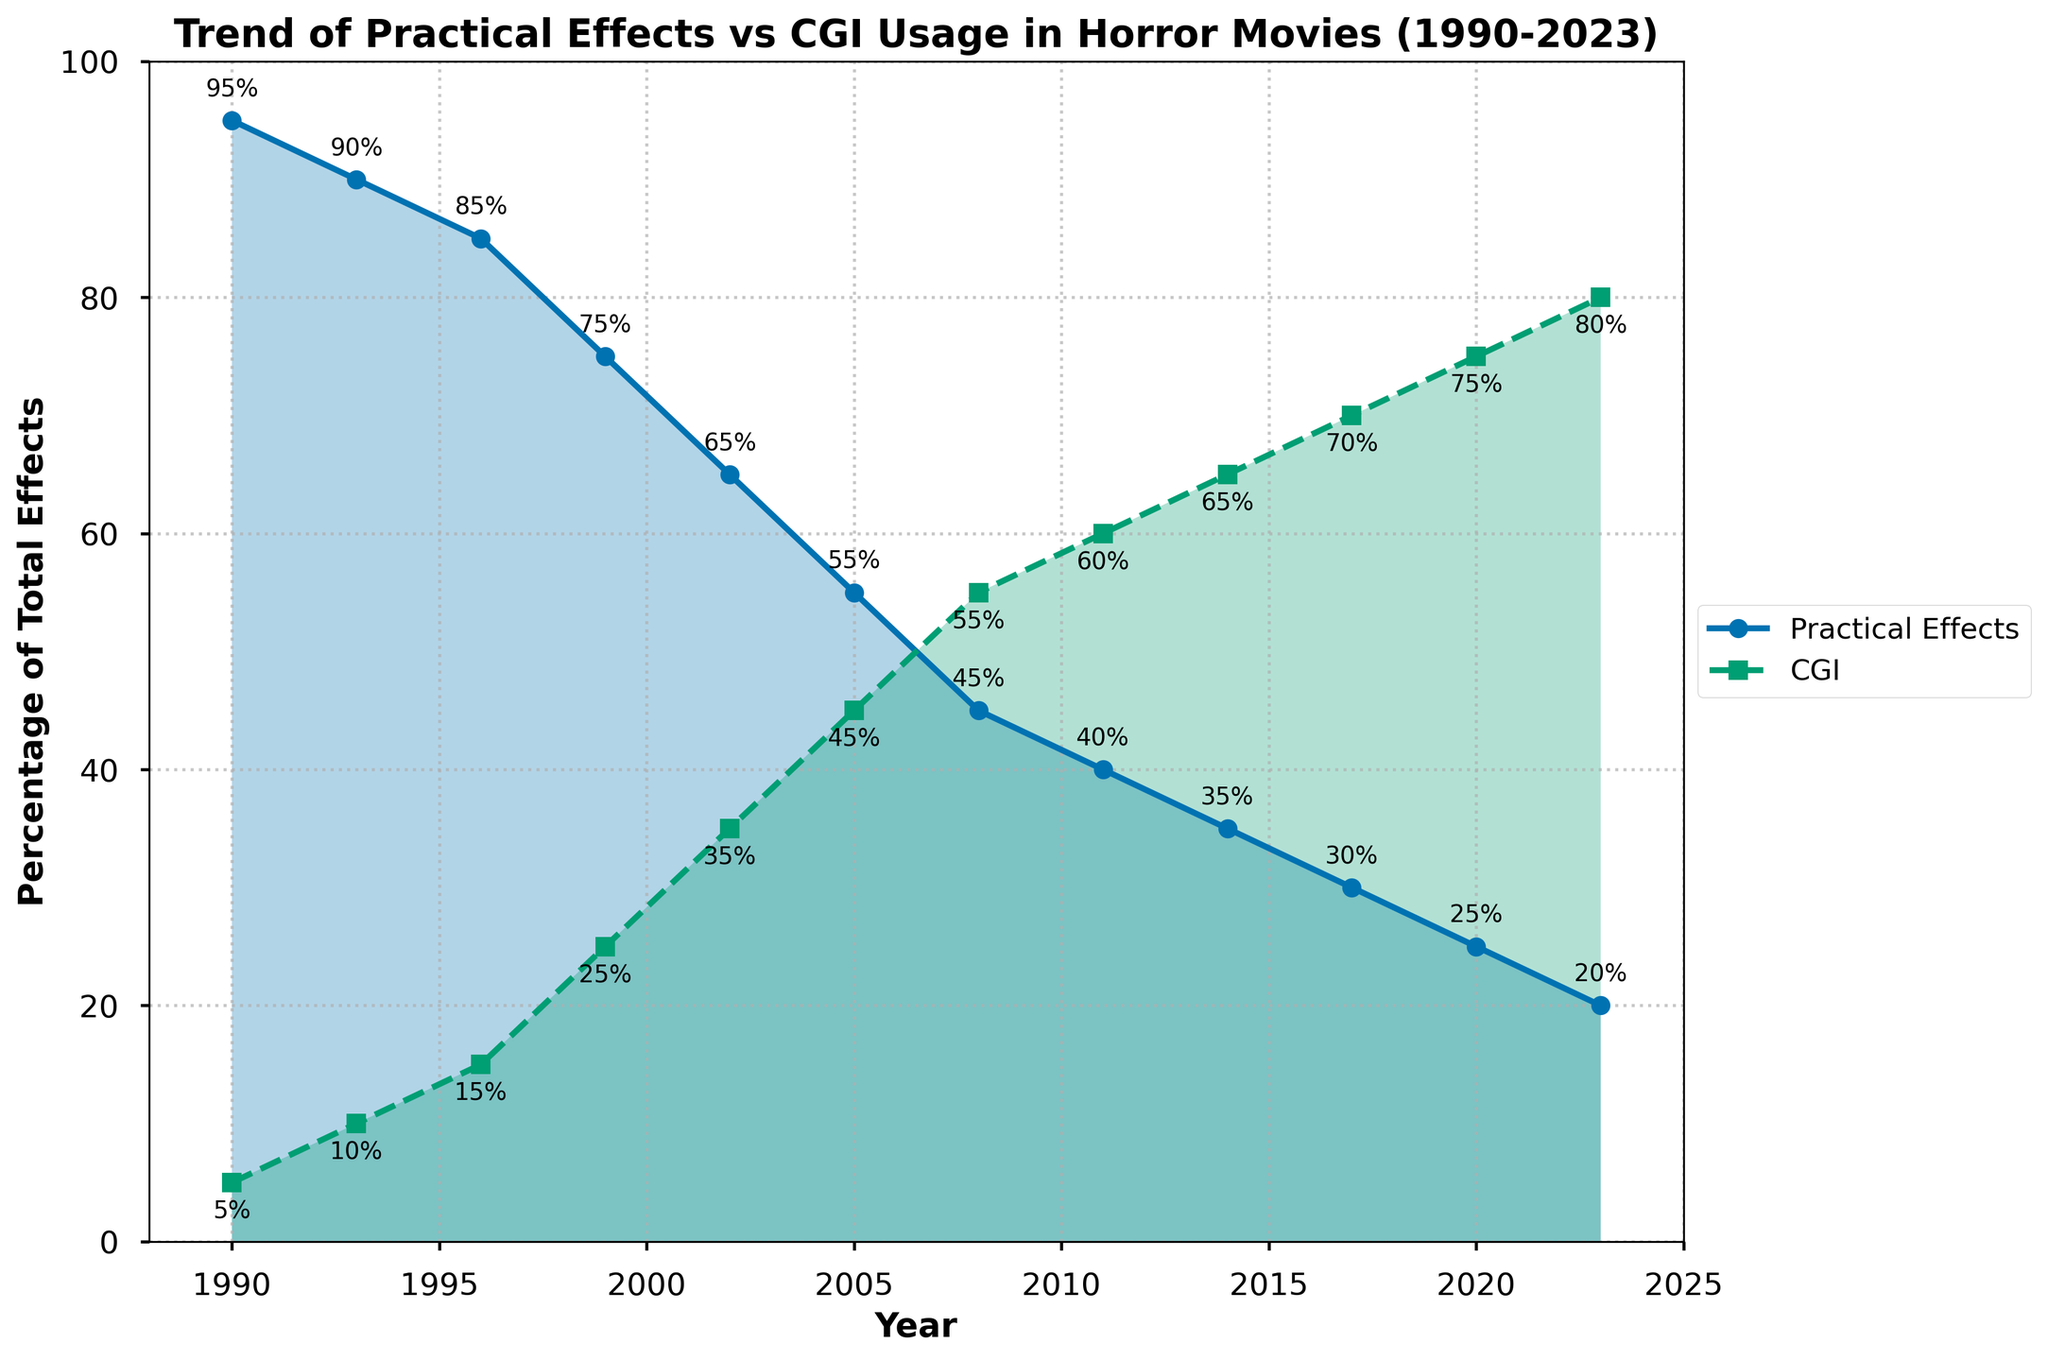What is the overall trend of practical effects usage from 1990 to 2023? The line representing practical effects shows a consistent decline from 95% in 1990 to 20% in 2023. The decline appears to be steady over the years.
Answer: Consistent decline In which year did CGI usage first surpass practical effects? CGI usage first surpasses practical effects in 2008 based on the crossover of the two lines.
Answer: 2008 What is the percentage difference in practical effects between 1990 and 2023? The percentage of practical effects in 1990 is 95%, and in 2023 it is 20%. The difference is calculated as 95% - 20% = 75%.
Answer: 75% Which year experienced the most significant decrease in practical effects relative to the previous period? The most significant decrease in practical effects occurred between 1999 (75%) and 2002 (65%), a drop of 10 percentage points.
Answer: 1999-2002 By how much did CGI usage increase from 1999 to 2023? CGI usage in 1999 was 25%, and in 2023 it is 80%. The increase is calculated as 80% - 25% = 55%.
Answer: 55% How do practical effects and CGI trends compare between 1996 and 2005? Practical effects decreased from 85% in 1996 to 55% in 2005, while CGI increased from 15% in 1996 to 45% in 2005, indicating a significant shift towards CGI.
Answer: Shift towards CGI What visual attribute differentiates the trend lines for practical effects and CGI? The trend line for practical effects is solid with circles as markers, while the trend line for CGI is dashed with squares as markers. These visual attributes help to easily distinguish between the two trends.
Answer: Line style and markers What is the percentage of practical effects in 2011 and how does it compare to CGI usage in the same year? In 2011, practical effects are at 40%, while CGI usage is at 60%. Practical effects are 20 percentage points lower than CGI in 2011.
Answer: 40%, 20 points lower During which period is the decrease in practical effects usage consistent without significant fluctuation? From 2011 to 2023, the decrease in practical effects usage appears consistent without significant fluctuation, steadily decreasing from 40% to 20%.
Answer: 2011-2023 On average, how much did the practical effects percentage decrease per year from 1990 to 2023? Practical effects decreased from 95% in 1990 to 20% in 2023, over 33 years. The average annual decrease is calculated as (95% - 20%) / 33 ≈ 2.27% per year.
Answer: ≈ 2.27% per year 